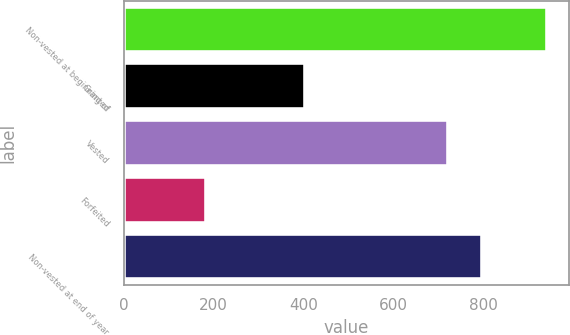Convert chart to OTSL. <chart><loc_0><loc_0><loc_500><loc_500><bar_chart><fcel>Non-vested at beginning of<fcel>Granted<fcel>Vested<fcel>Forfeited<fcel>Non-vested at end of year<nl><fcel>941<fcel>404<fcel>721<fcel>182<fcel>796.9<nl></chart> 